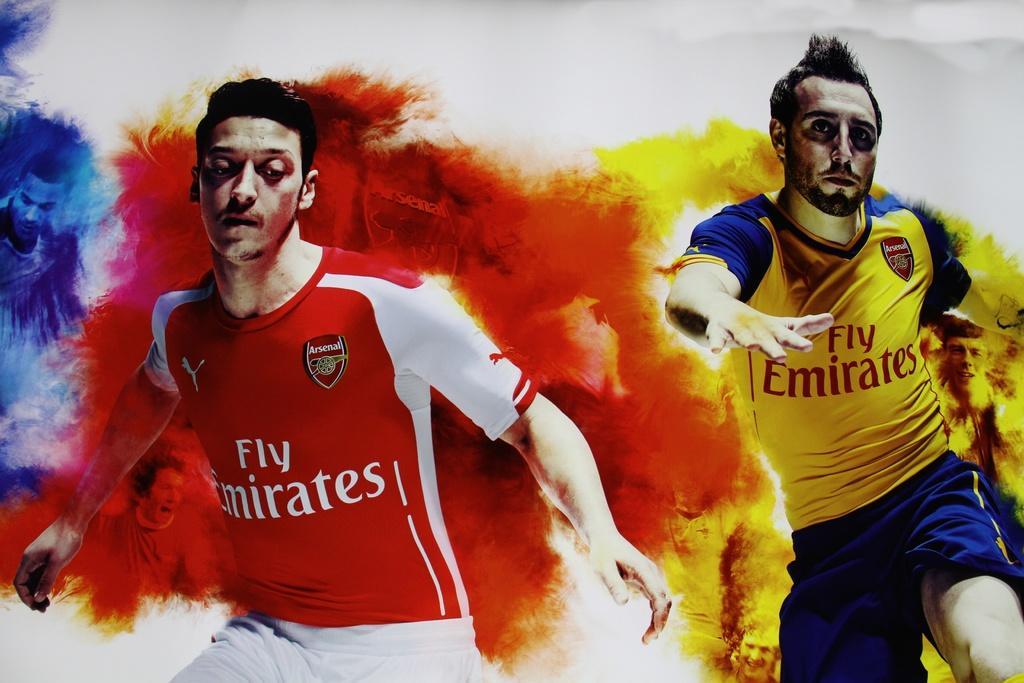Please provide a concise description of this image. In this picture there are two men. A man towards the left, he is wearing a red t shirt and white shorts. Towards the right, there is another man in yellow t shirt and blue shorts. In the background there are colors. 